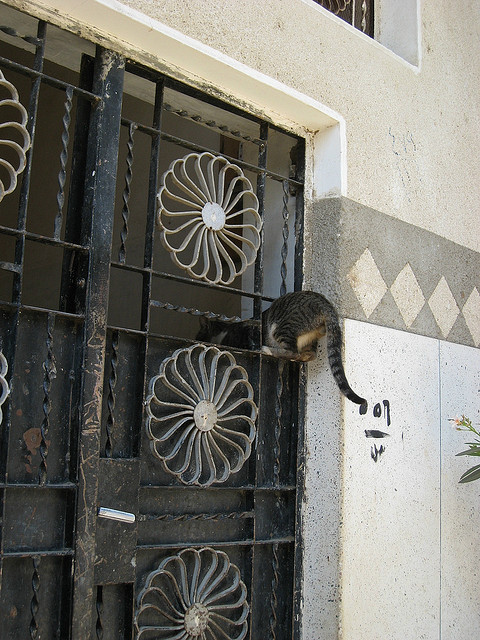<image>Where's the smiley face? There is no smiley face in the image. However, some might interpret one on the wall. Where's the smiley face? I don't know where the smiley face is. It could be on the wall or it might not be visible in the image. 